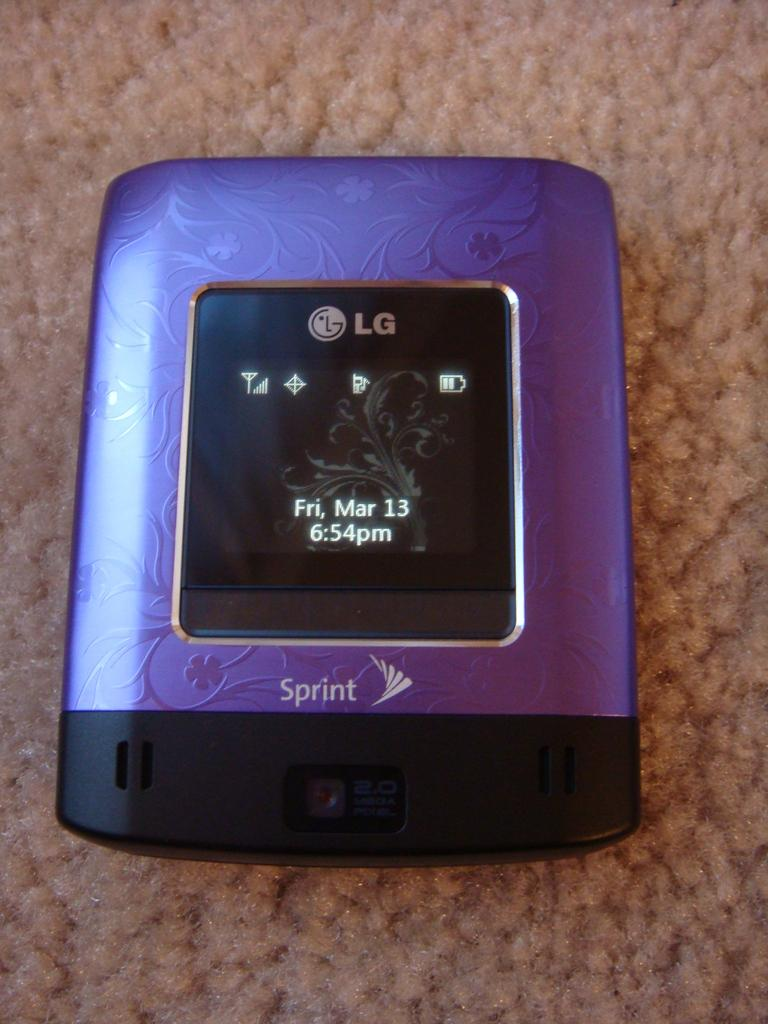<image>
Write a terse but informative summary of the picture. A purple and black LG cellular device with a 2 mega pixel camera running on the Sprint network. 